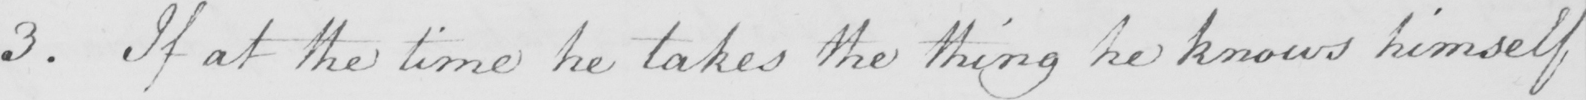What does this handwritten line say? 3 . If at the time he takes the thing he knows himself 